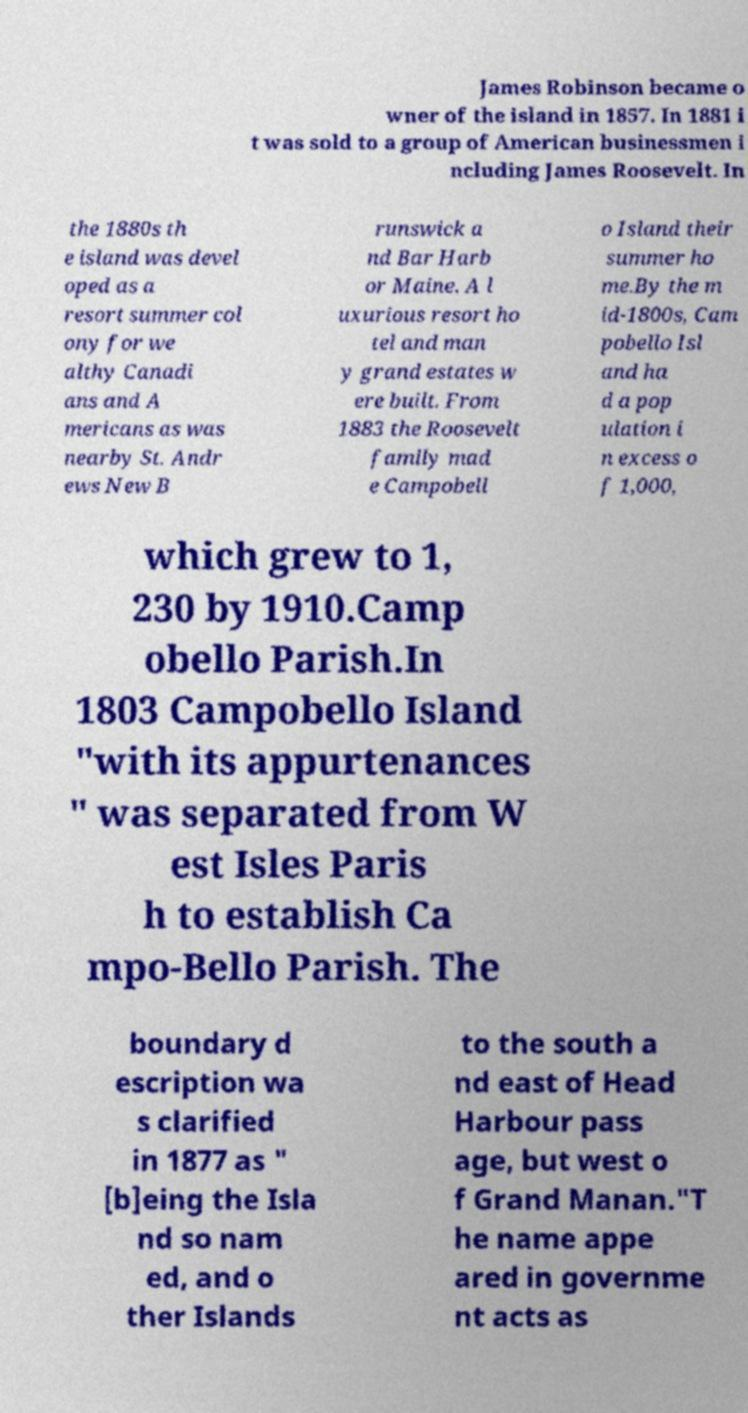I need the written content from this picture converted into text. Can you do that? James Robinson became o wner of the island in 1857. In 1881 i t was sold to a group of American businessmen i ncluding James Roosevelt. In the 1880s th e island was devel oped as a resort summer col ony for we althy Canadi ans and A mericans as was nearby St. Andr ews New B runswick a nd Bar Harb or Maine. A l uxurious resort ho tel and man y grand estates w ere built. From 1883 the Roosevelt family mad e Campobell o Island their summer ho me.By the m id-1800s, Cam pobello Isl and ha d a pop ulation i n excess o f 1,000, which grew to 1, 230 by 1910.Camp obello Parish.In 1803 Campobello Island "with its appurtenances " was separated from W est Isles Paris h to establish Ca mpo-Bello Parish. The boundary d escription wa s clarified in 1877 as " [b]eing the Isla nd so nam ed, and o ther Islands to the south a nd east of Head Harbour pass age, but west o f Grand Manan."T he name appe ared in governme nt acts as 